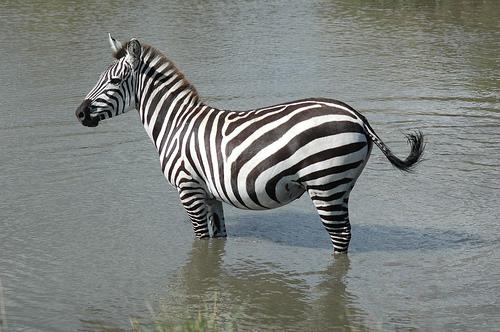Is the zebra standing in water?
Short answer required. Yes. What is the animal looking down at?
Concise answer only. Water. Is the zebra in a zoo?
Concise answer only. No. What color are the zebra's stripes?
Be succinct. Black. What is the zebra doing?
Give a very brief answer. Wading. How many animals are there?
Keep it brief. 1. Are these animals contained?
Concise answer only. No. 